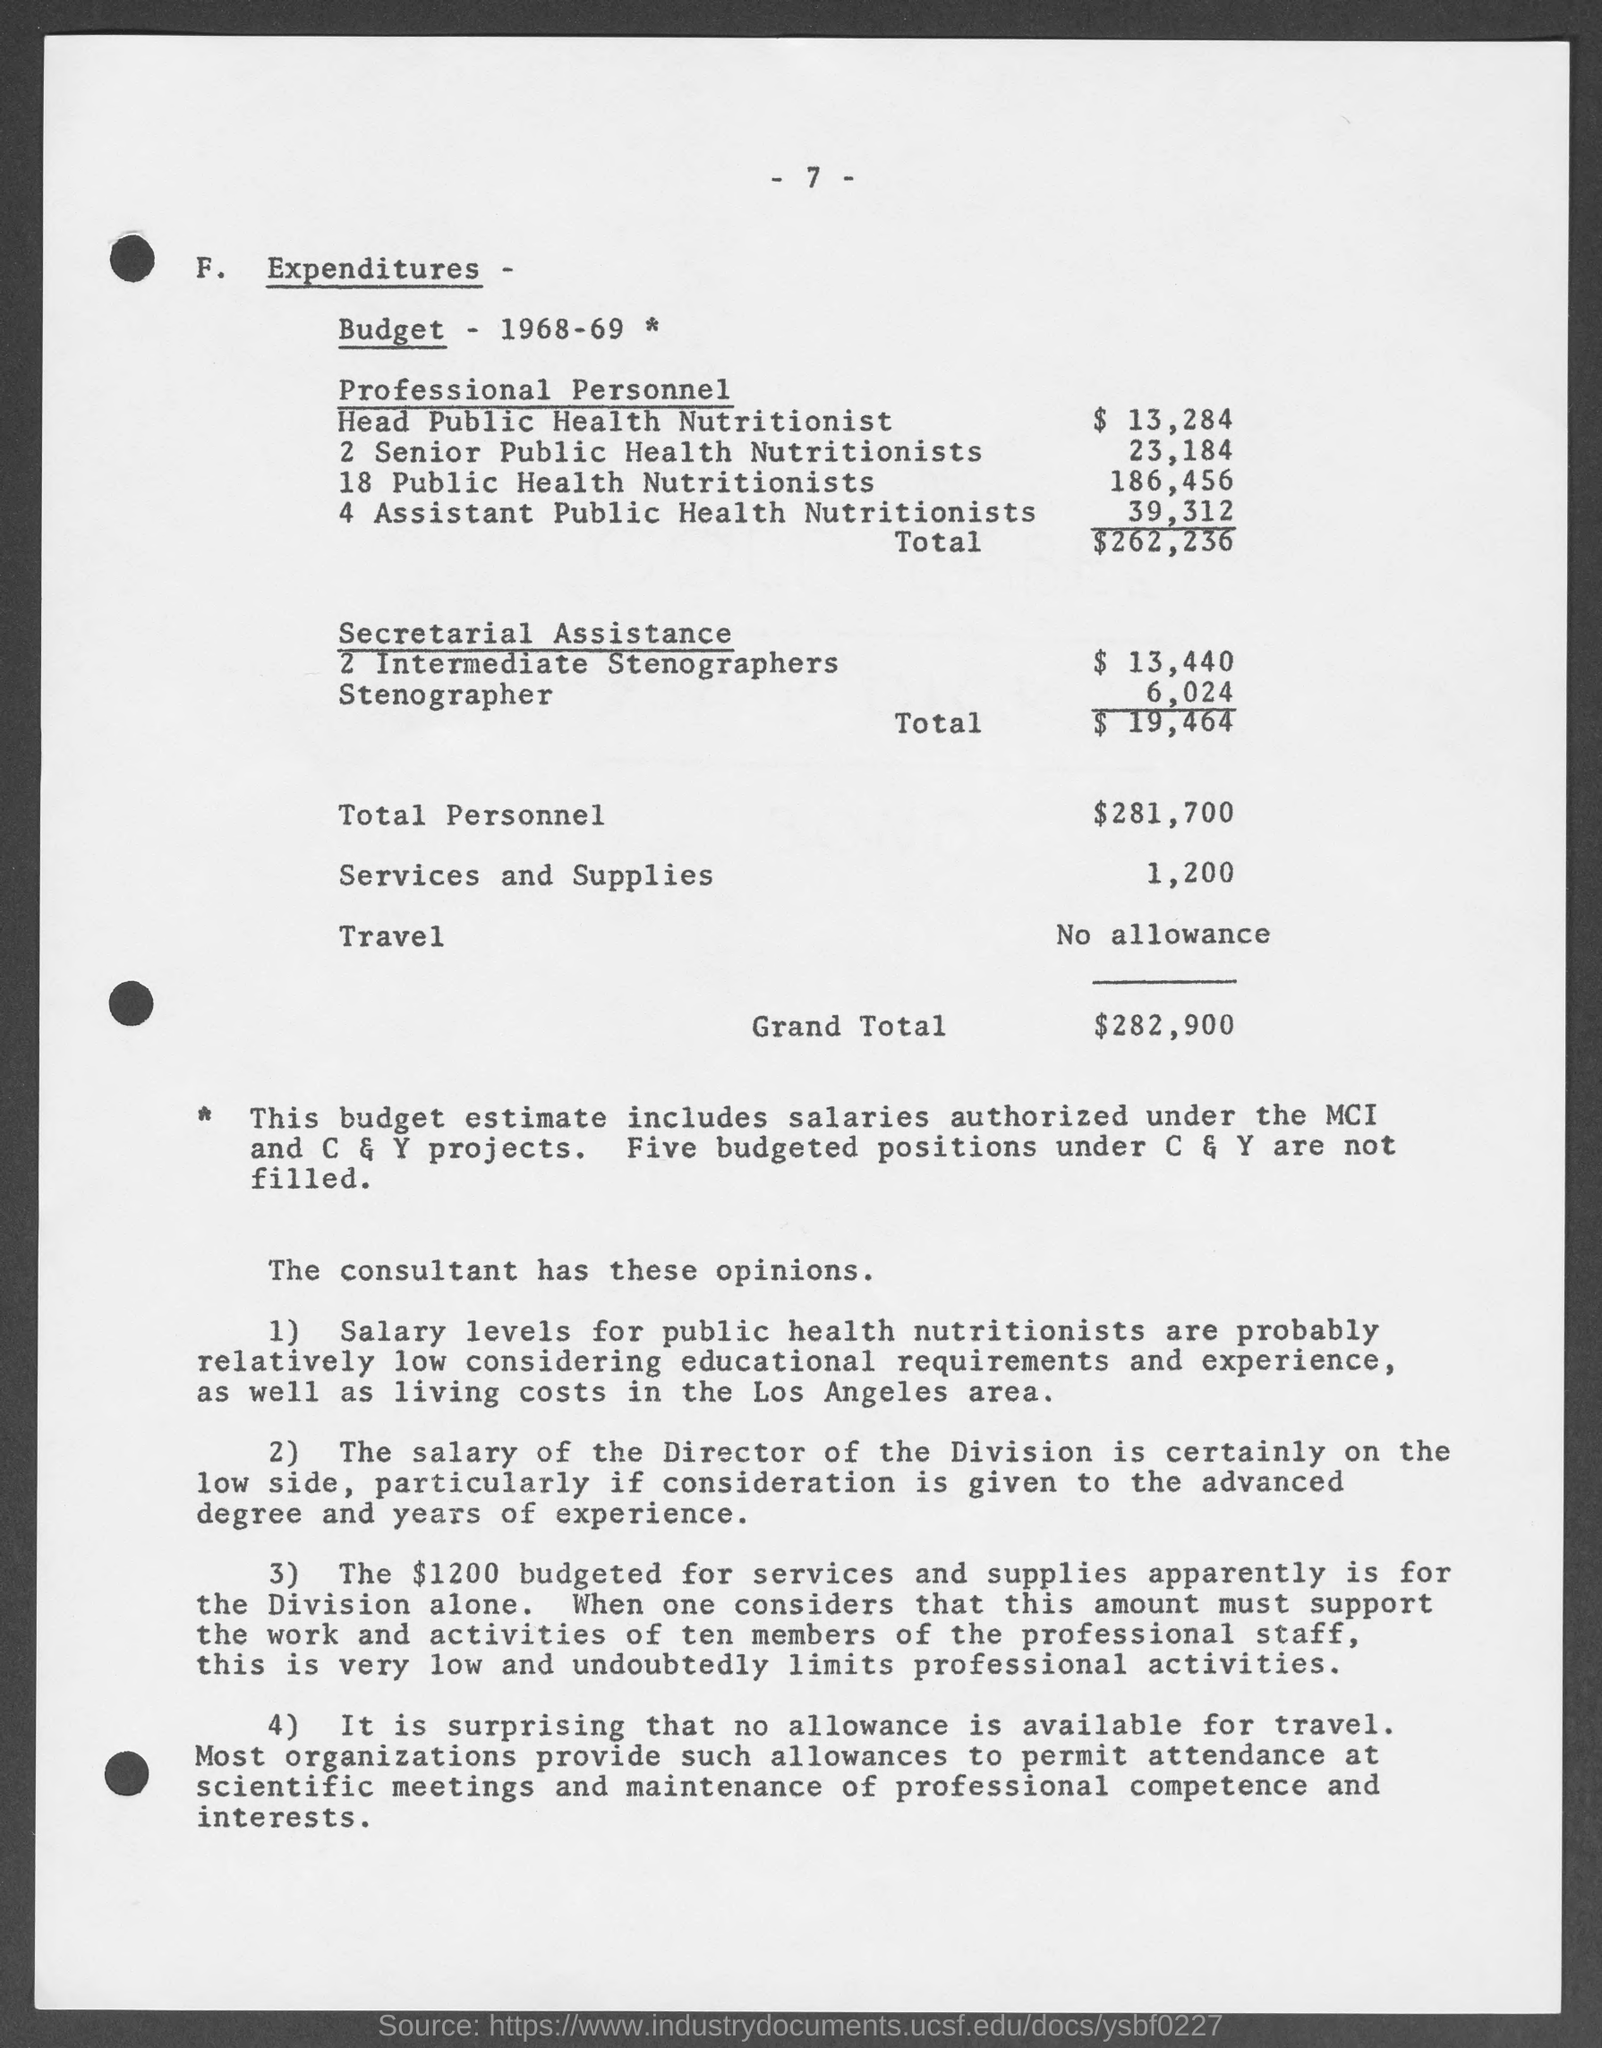Draw attention to some important aspects in this diagram. The total personnel budget for the year 1968-69 was 281,700. The total budget estimate for professional personnel in the year 1968-69 was $262,236. According to the budget estimate for the year 1968-1969, a total of 18 Public Health Nutritionists were allocated a budget of 186,456. The total budget estimate for Secretarial Assistance in the year 1968-1969 was 19,464. The estimated budget for a stenographer in the year 1968-69 was $6,024. 